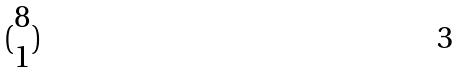<formula> <loc_0><loc_0><loc_500><loc_500>( \begin{matrix} 8 \\ 1 \end{matrix} )</formula> 